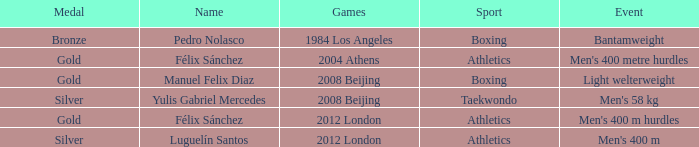Which Medal had a Name of félix sánchez, and a Games of 2012 london? Gold. 